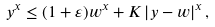Convert formula to latex. <formula><loc_0><loc_0><loc_500><loc_500>y ^ { x } \leq ( 1 + \varepsilon ) w ^ { x } + K \left | y - w \right | ^ { x } ,</formula> 